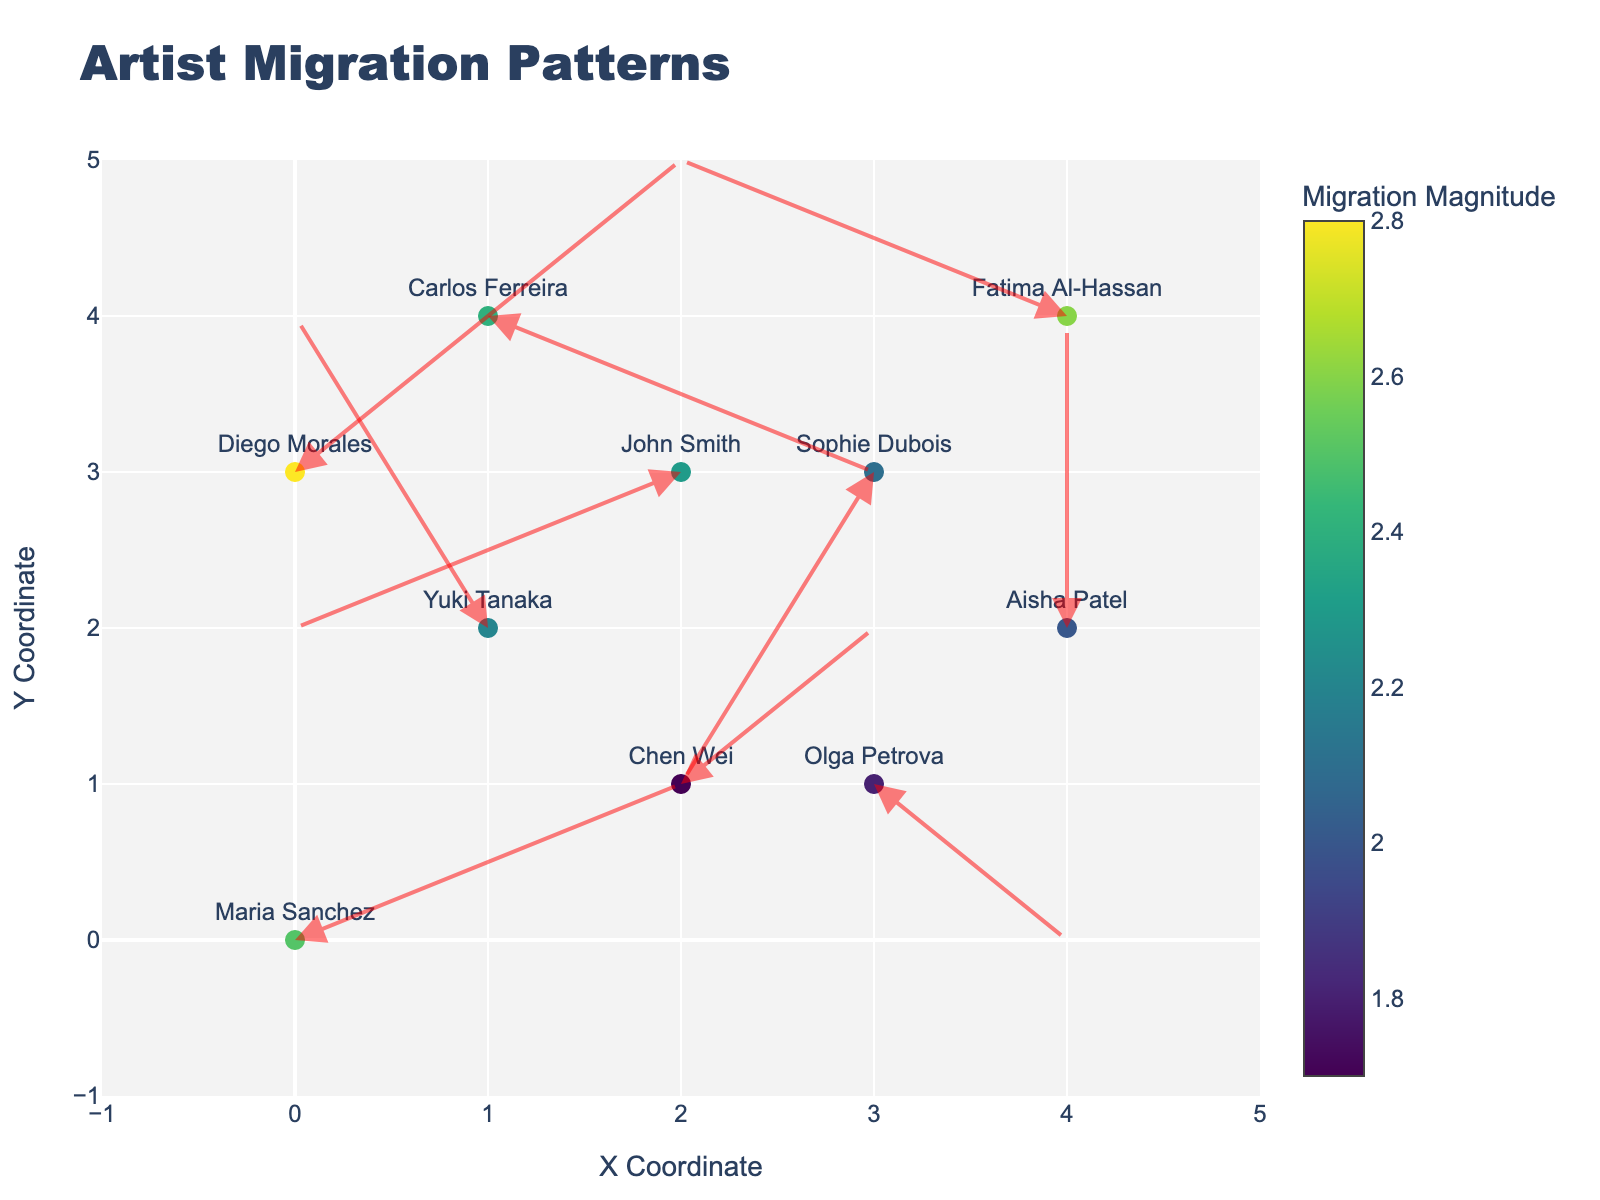What is the title of the plot? The title can be found at the top center of the figure. It is usually displayed in a larger font size compared to other texts in the plot.
Answer: Artist Migration Patterns How many artists are represented in the plot? Each artist is represented by a marker on the plot. By counting all the markers, you can determine the total number of artists.
Answer: 10 Which artist has the highest migration magnitude? The color intensity of the markers varies with the migration magnitude. By identifying the darkest marker and hovering over it, you can see the corresponding artist’s name and migration magnitude.
Answer: Diego Morales Which artist's migration path ends at coordinates (3, 4)? Look for a marker on the plot at coordinates (3, 4). Hovering over the marker will display the artist’s name and migration information.
Answer: Sophie Dubois How many artists moved from a city with a negative x-coordinate change? Negative x-coordinate change indicates a movement to the left. Look for arrows pointing to the left (u values are negative). Count how many such arrows exist on the plot.
Answer: 4 Which two artists have moved in almost opposite directions? Look for arrows that point in almost opposite directions. For example, arrows with directions (2,1) and (-2,-1) are opposites.
Answer: Maria Sanchez and John Smith What is the average migration magnitude of all artists? Sum the magnitude values for all artists and divide by the total number of artists. The magnitude values are provided in the data. \[(2.5 + 2.2 + 1.8 + 2.3 + 2.0 + 2.4 + 2.1 + 1.7 + 2.6 + 2.8) / 10 = 2.24\]
Answer: 2.24 Is there any artist who moved strictly upwards without any sideways migration? Look for arrows that point straight up (u value is 0 and v value is positive). Check the arrow starting at (4, 2).
Answer: Aisha Patel Which city pairs have the smallest and largest migration magnitudes, respectively? Look for markers with the lightest and darkest colors, respectively, to find the cities involved in those migrations.
Answer: Moscow to Berlin, Buenos Aires to Miami Are there any artists who moved from one continent to another? If so, who are they? Identify artists with origins and destinations in different continents by considering city-to-city information provided in the hover text.
Answer: Multiple artists including John Smith (London to Sydney) and Chen Wei (Beijing to Vancouver) 